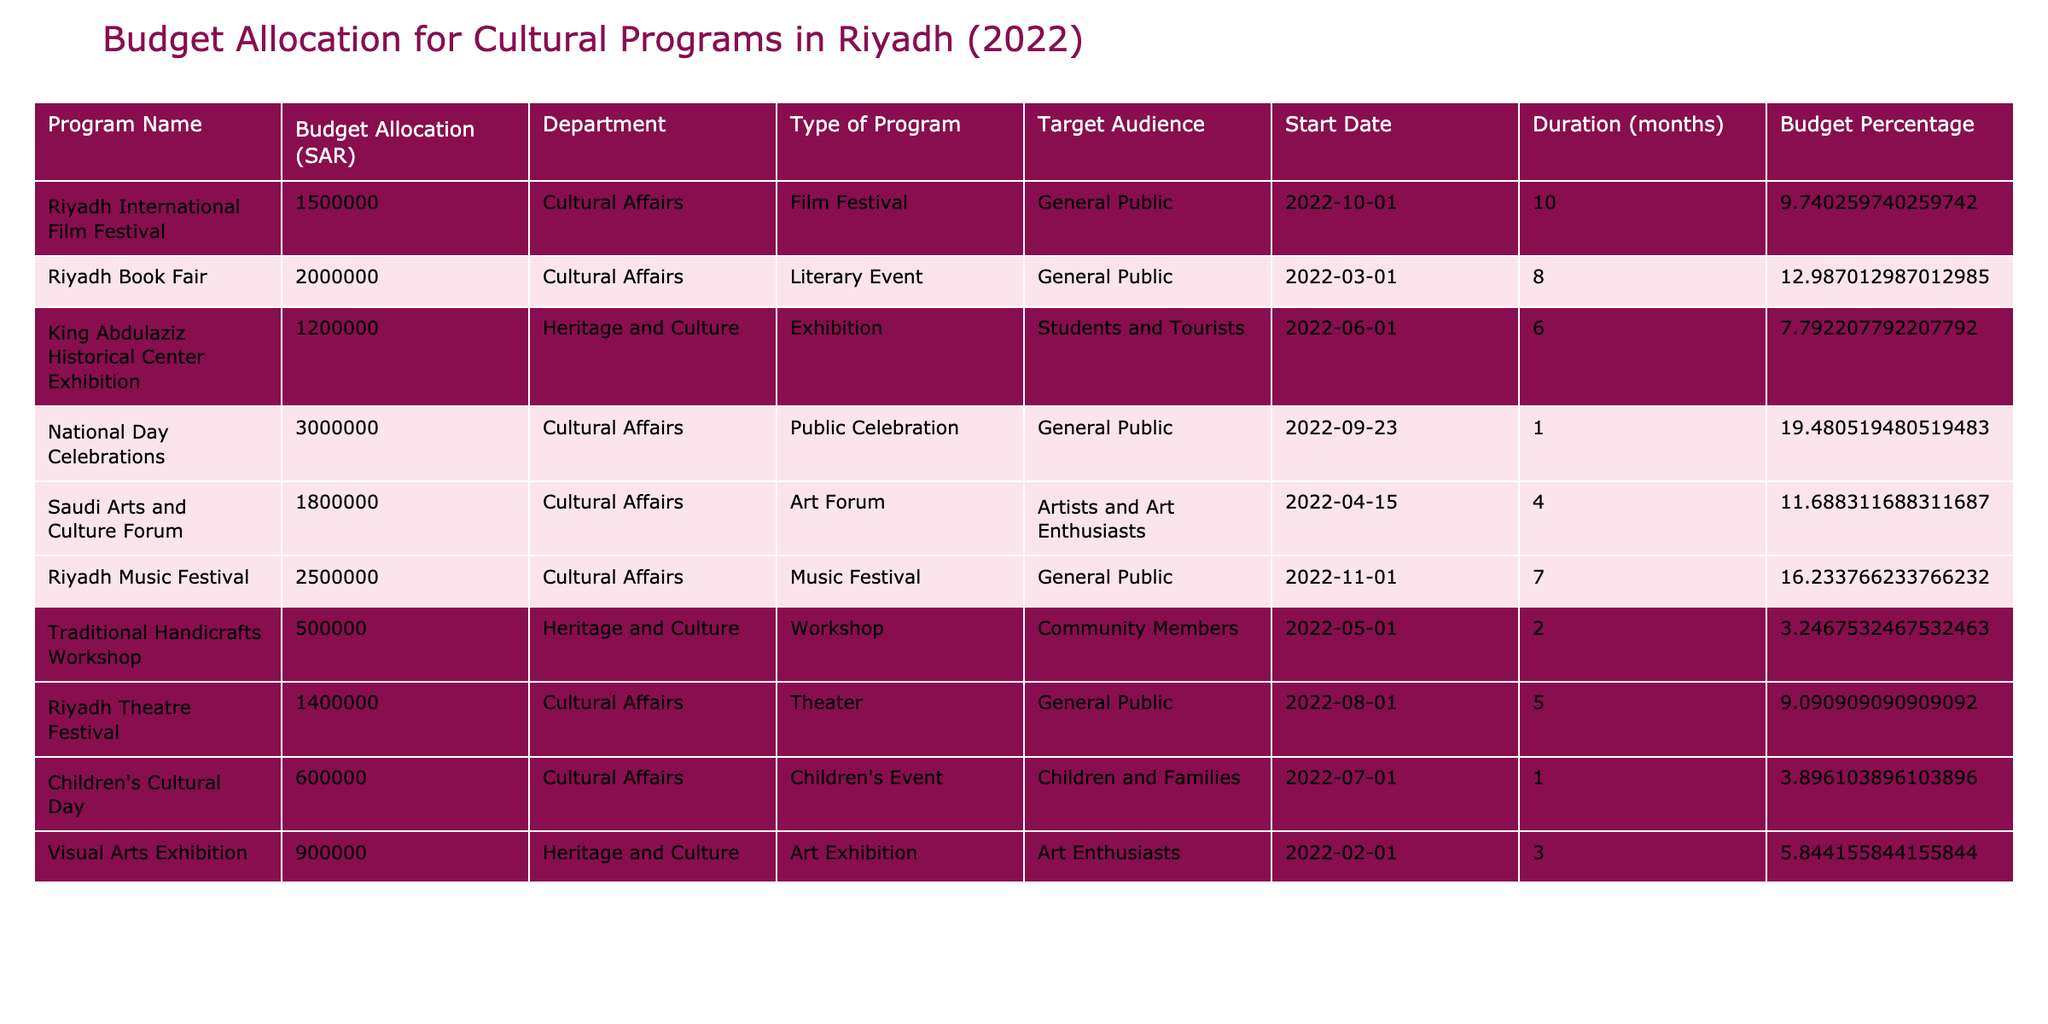What is the total budget allocation for cultural programs in Riyadh in 2022? To find the total budget allocation, sum the values in the "Budget Allocation (SAR)" column: 1,500,000 + 2,000,000 + 1,200,000 + 3,000,000 + 1,800,000 + 2,500,000 + 500,000 + 1,400,000 + 600,000 + 900,000 = 15,100,000 SAR.
Answer: 15,100,000 SAR Which program received the highest budget allocation? By examining the "Budget Allocation (SAR)" values, the program with the highest allocation is "National Day Celebrations" with 3,000,000 SAR.
Answer: National Day Celebrations How many programs focused on "Cultural Affairs"? Count the entries under the "Department" column that are labeled "Cultural Affairs." There are six programs fitting this category.
Answer: 6 What is the budget allocation for the "Riyadh Music Festival"? The "Budget Allocation (SAR)" for the "Riyadh Music Festival" is clearly listed as 2,500,000 SAR.
Answer: 2,500,000 SAR Are there any programs specifically targeting children? Review the "Target Audience" column for instances of "Children." The "Children's Cultural Day" is the only program targeting this audience, indicating that there is indeed a program for children.
Answer: Yes What percentage of the total budget is allocated to the "Riyadh Book Fair"? First, find the budget allocation for the "Riyadh Book Fair," which is 2,000,000 SAR. Next, use the total budget (15,100,000 SAR) to calculate the percentage: (2,000,000 / 15,100,000) * 100 = 13.25%.
Answer: 13.25% What is the average duration (in months) of cultural programs that are exhibitions? Identify all programs of type "Exhibition" and their durations: King Abdulaziz Historical Center Exhibition (6 months) and Visual Arts Exhibition (3 months). The average duration = (6 + 3) / 2 = 4.5 months.
Answer: 4.5 months How much more budget was allocated to the "Riyadh Music Festival" compared to the "Traditional Handicrafts Workshop"? Determine the budget allocations: "Riyadh Music Festival" has 2,500,000 SAR and "Traditional Handicrafts Workshop" has 500,000 SAR. The difference is 2,500,000 - 500,000 = 2,000,000 SAR.
Answer: 2,000,000 SAR Is there a program focusing on community members? Check the "Target Audience" column; the "Traditional Handicrafts Workshop" specifically targets community members, confirming there is a program for them.
Answer: Yes What is the combined budget for programs that last more than 6 months? Identify the programs with a duration greater than 6 months: "Riyadh International Film Festival" (10 months) and "Riyadh Book Fair" (8 months). The combined budget is 1,500,000 + 2,000,000 = 3,500,000 SAR.
Answer: 3,500,000 SAR 